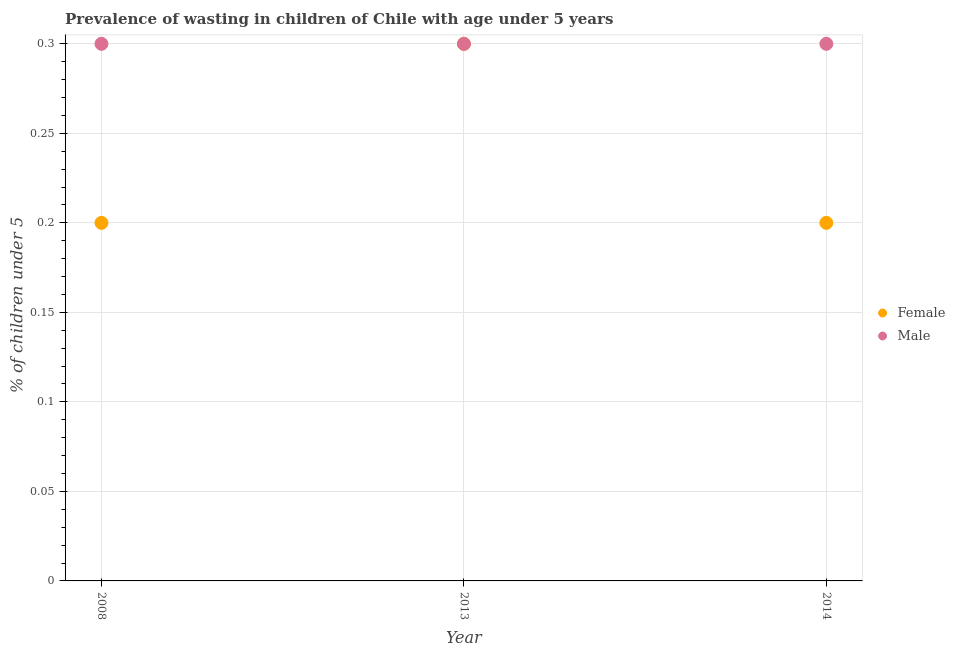How many different coloured dotlines are there?
Offer a very short reply. 2. What is the percentage of undernourished male children in 2013?
Your response must be concise. 0.3. Across all years, what is the maximum percentage of undernourished male children?
Offer a terse response. 0.3. Across all years, what is the minimum percentage of undernourished female children?
Make the answer very short. 0.2. In which year was the percentage of undernourished female children maximum?
Keep it short and to the point. 2013. What is the total percentage of undernourished male children in the graph?
Your answer should be very brief. 0.9. What is the difference between the percentage of undernourished female children in 2014 and the percentage of undernourished male children in 2008?
Keep it short and to the point. -0.1. What is the average percentage of undernourished male children per year?
Keep it short and to the point. 0.3. In how many years, is the percentage of undernourished male children greater than 0.27 %?
Provide a short and direct response. 3. What is the difference between the highest and the second highest percentage of undernourished female children?
Make the answer very short. 0.1. What is the difference between the highest and the lowest percentage of undernourished female children?
Your answer should be compact. 0.1. Is the percentage of undernourished female children strictly less than the percentage of undernourished male children over the years?
Keep it short and to the point. No. How many dotlines are there?
Make the answer very short. 2. How many years are there in the graph?
Your answer should be compact. 3. Are the values on the major ticks of Y-axis written in scientific E-notation?
Your answer should be very brief. No. Does the graph contain any zero values?
Keep it short and to the point. No. Where does the legend appear in the graph?
Keep it short and to the point. Center right. How many legend labels are there?
Your answer should be compact. 2. How are the legend labels stacked?
Make the answer very short. Vertical. What is the title of the graph?
Keep it short and to the point. Prevalence of wasting in children of Chile with age under 5 years. What is the label or title of the X-axis?
Your response must be concise. Year. What is the label or title of the Y-axis?
Offer a terse response.  % of children under 5. What is the  % of children under 5 of Female in 2008?
Offer a terse response. 0.2. What is the  % of children under 5 in Male in 2008?
Ensure brevity in your answer.  0.3. What is the  % of children under 5 in Female in 2013?
Offer a terse response. 0.3. What is the  % of children under 5 of Male in 2013?
Offer a very short reply. 0.3. What is the  % of children under 5 of Female in 2014?
Provide a short and direct response. 0.2. What is the  % of children under 5 in Male in 2014?
Ensure brevity in your answer.  0.3. Across all years, what is the maximum  % of children under 5 in Female?
Your answer should be very brief. 0.3. Across all years, what is the maximum  % of children under 5 in Male?
Give a very brief answer. 0.3. Across all years, what is the minimum  % of children under 5 of Female?
Offer a very short reply. 0.2. Across all years, what is the minimum  % of children under 5 of Male?
Your answer should be compact. 0.3. What is the total  % of children under 5 of Female in the graph?
Offer a terse response. 0.7. What is the total  % of children under 5 of Male in the graph?
Keep it short and to the point. 0.9. What is the difference between the  % of children under 5 of Male in 2008 and that in 2013?
Offer a terse response. 0. What is the difference between the  % of children under 5 of Male in 2008 and that in 2014?
Your answer should be compact. 0. What is the difference between the  % of children under 5 in Female in 2013 and that in 2014?
Make the answer very short. 0.1. What is the average  % of children under 5 in Female per year?
Offer a very short reply. 0.23. What is the average  % of children under 5 in Male per year?
Provide a succinct answer. 0.3. In the year 2008, what is the difference between the  % of children under 5 in Female and  % of children under 5 in Male?
Provide a short and direct response. -0.1. In the year 2014, what is the difference between the  % of children under 5 of Female and  % of children under 5 of Male?
Provide a short and direct response. -0.1. What is the ratio of the  % of children under 5 of Female in 2008 to that in 2014?
Keep it short and to the point. 1. What is the ratio of the  % of children under 5 of Male in 2008 to that in 2014?
Keep it short and to the point. 1. What is the ratio of the  % of children under 5 of Female in 2013 to that in 2014?
Ensure brevity in your answer.  1.5. What is the difference between the highest and the second highest  % of children under 5 in Male?
Provide a succinct answer. 0. 